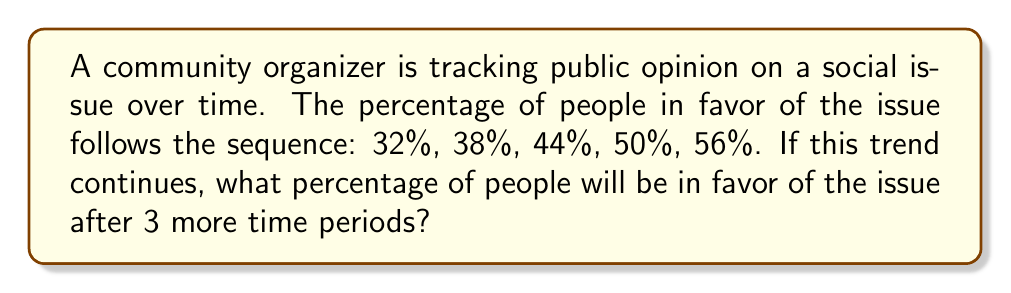Give your solution to this math problem. To solve this problem, we need to:

1. Identify the pattern in the given sequence
2. Extend the pattern for 3 more time periods

Step 1: Identify the pattern

Let's look at the differences between consecutive terms:

$38\% - 32\% = 6\%$
$44\% - 38\% = 6\%$
$50\% - 44\% = 6\%$
$56\% - 50\% = 6\%$

We can see that the percentage increases by 6% each time period. This is an arithmetic sequence with a common difference of 6.

Step 2: Extend the pattern

We need to add 6% three more times to the last given term (56%):

Time period 6: $56\% + 6\% = 62\%$
Time period 7: $62\% + 6\% = 68\%$
Time period 8: $68\% + 6\% = 74\%$

Alternatively, we can use the arithmetic sequence formula:

$a_n = a_1 + (n-1)d$

Where $a_n$ is the nth term, $a_1$ is the first term, $n$ is the position of the term, and $d$ is the common difference.

In this case, $a_1 = 32\%$, $d = 6\%$, and we want the 8th term:

$a_8 = 32\% + (8-1) \cdot 6\%$
$a_8 = 32\% + 7 \cdot 6\%$
$a_8 = 32\% + 42\%$
$a_8 = 74\%$

Therefore, after 3 more time periods, 74% of people will be in favor of the issue.
Answer: 74% 